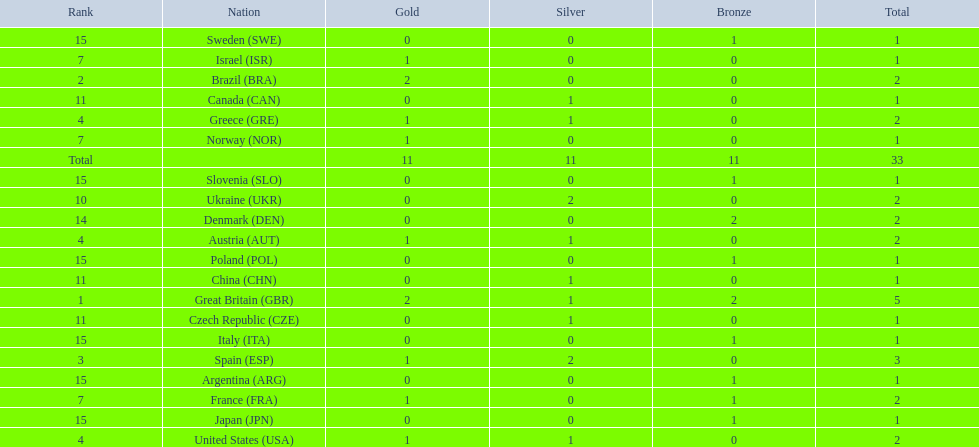Which nation was the only one to receive 3 medals? Spain (ESP). 